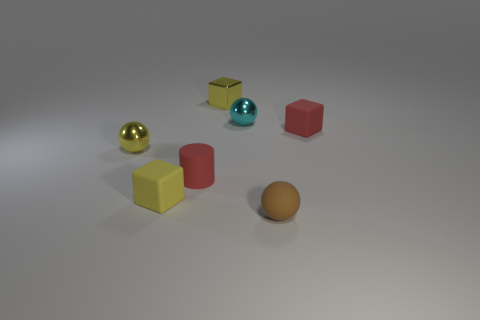Are there an equal number of tiny yellow balls to the left of the yellow rubber object and big cyan things?
Provide a short and direct response. No. Do the red cylinder and the matte sphere have the same size?
Provide a short and direct response. Yes. Is there a shiny cube in front of the matte cube behind the tiny red rubber object that is in front of the tiny yellow ball?
Give a very brief answer. No. There is a small yellow thing that is the same shape as the cyan thing; what is its material?
Make the answer very short. Metal. There is a cyan metal ball that is to the right of the red cylinder; what number of small yellow cubes are to the right of it?
Your response must be concise. 0. How big is the yellow object that is behind the small matte cube that is right of the brown rubber ball to the left of the tiny red matte block?
Make the answer very short. Small. The small matte cube behind the rubber cube that is on the left side of the tiny brown ball is what color?
Ensure brevity in your answer.  Red. What number of other things are there of the same material as the red block
Your answer should be very brief. 3. How many other things are the same color as the metal cube?
Offer a terse response. 2. What is the material of the red object to the left of the yellow metallic object that is on the right side of the tiny cylinder?
Ensure brevity in your answer.  Rubber. 